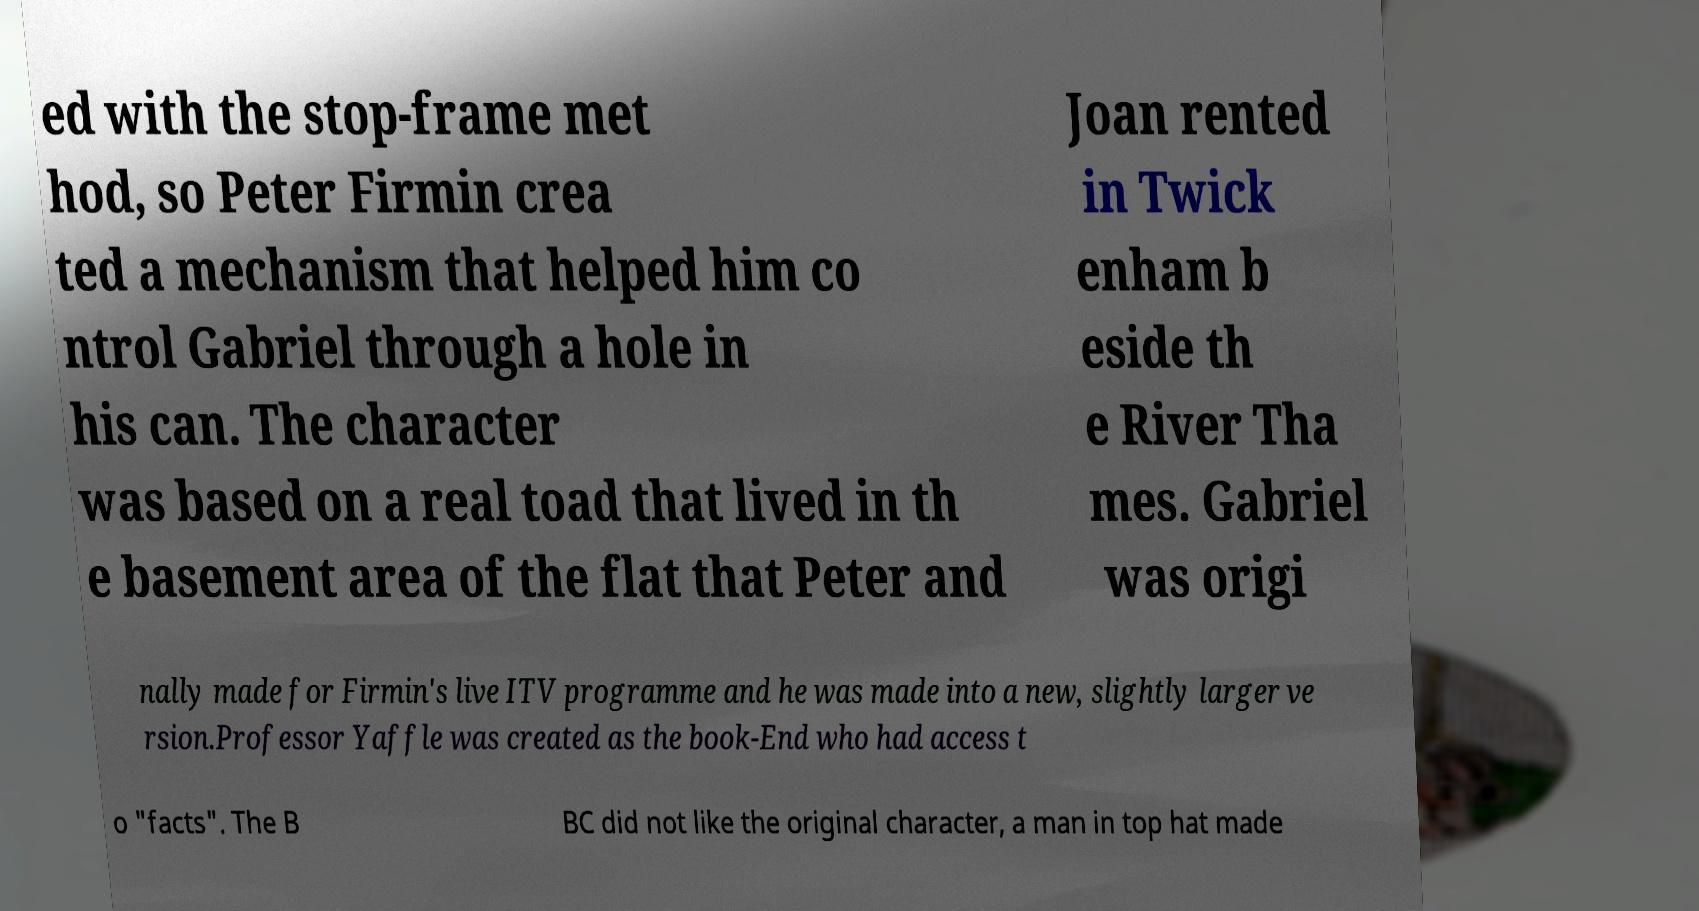Can you read and provide the text displayed in the image?This photo seems to have some interesting text. Can you extract and type it out for me? ed with the stop-frame met hod, so Peter Firmin crea ted a mechanism that helped him co ntrol Gabriel through a hole in his can. The character was based on a real toad that lived in th e basement area of the flat that Peter and Joan rented in Twick enham b eside th e River Tha mes. Gabriel was origi nally made for Firmin's live ITV programme and he was made into a new, slightly larger ve rsion.Professor Yaffle was created as the book-End who had access t o "facts". The B BC did not like the original character, a man in top hat made 